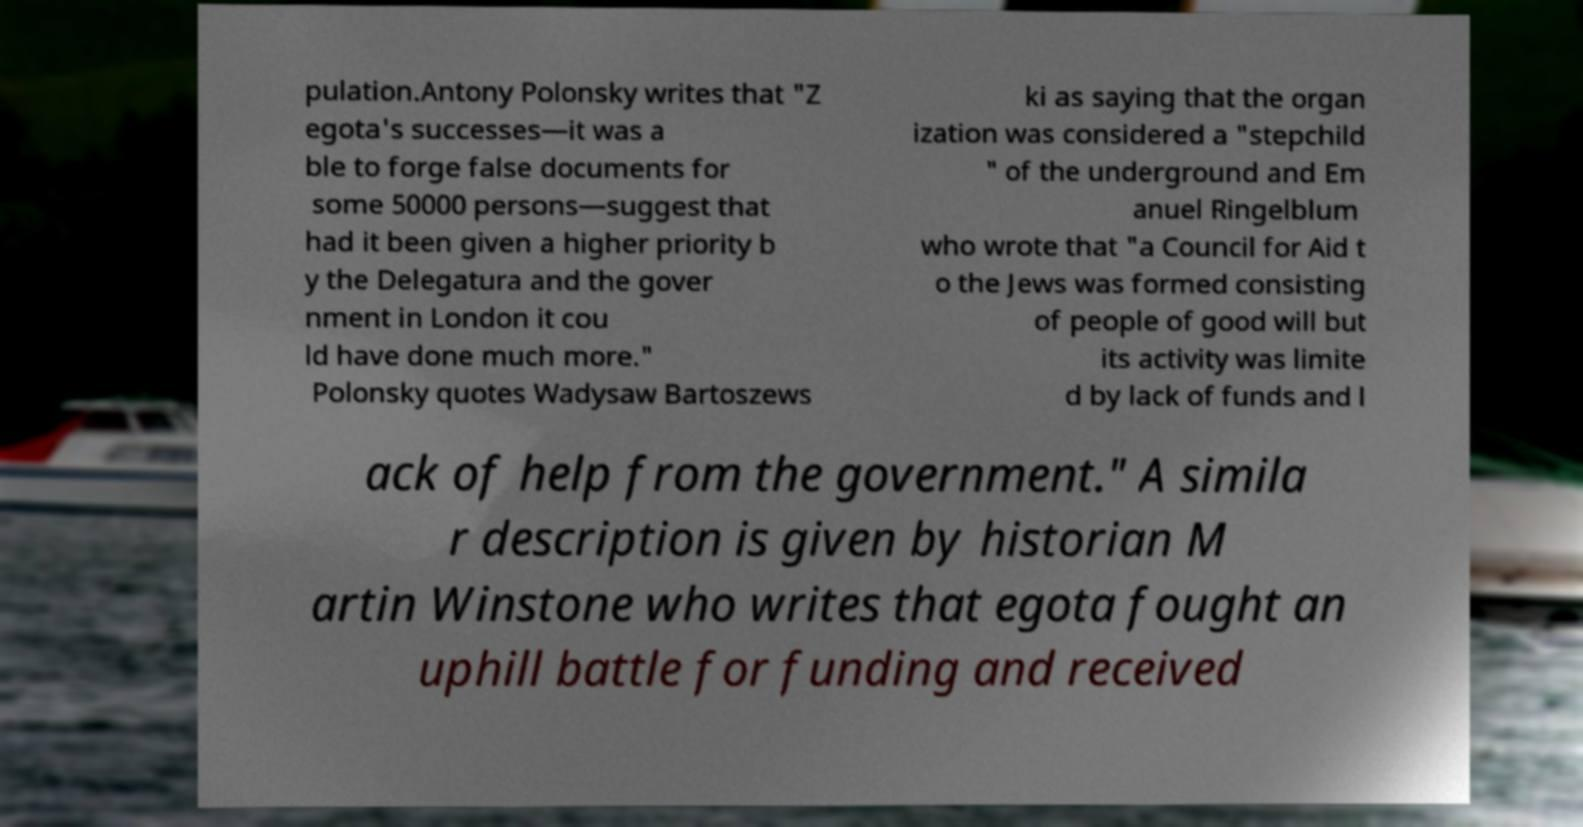What messages or text are displayed in this image? I need them in a readable, typed format. pulation.Antony Polonsky writes that "Z egota's successes—it was a ble to forge false documents for some 50000 persons—suggest that had it been given a higher priority b y the Delegatura and the gover nment in London it cou ld have done much more." Polonsky quotes Wadysaw Bartoszews ki as saying that the organ ization was considered a "stepchild " of the underground and Em anuel Ringelblum who wrote that "a Council for Aid t o the Jews was formed consisting of people of good will but its activity was limite d by lack of funds and l ack of help from the government." A simila r description is given by historian M artin Winstone who writes that egota fought an uphill battle for funding and received 